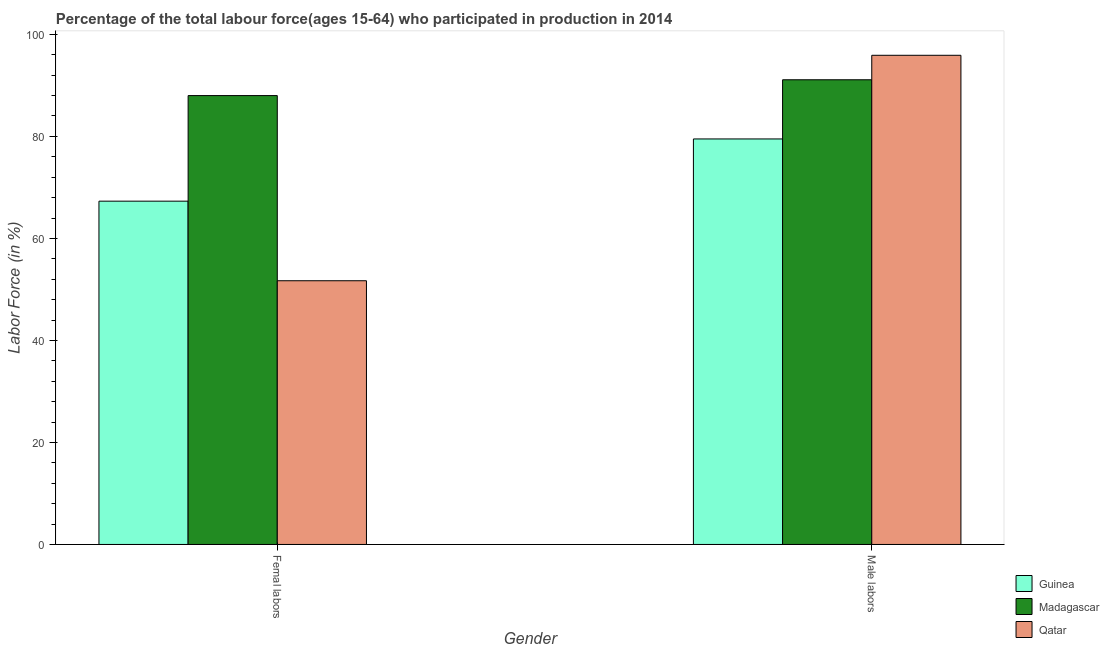How many groups of bars are there?
Your answer should be compact. 2. Are the number of bars on each tick of the X-axis equal?
Ensure brevity in your answer.  Yes. How many bars are there on the 2nd tick from the right?
Give a very brief answer. 3. What is the label of the 2nd group of bars from the left?
Provide a succinct answer. Male labors. Across all countries, what is the maximum percentage of female labor force?
Keep it short and to the point. 88. Across all countries, what is the minimum percentage of female labor force?
Your answer should be compact. 51.7. In which country was the percentage of male labour force maximum?
Give a very brief answer. Qatar. In which country was the percentage of male labour force minimum?
Offer a very short reply. Guinea. What is the total percentage of female labor force in the graph?
Provide a short and direct response. 207. What is the difference between the percentage of male labour force in Qatar and that in Madagascar?
Offer a terse response. 4.8. What is the difference between the percentage of female labor force in Guinea and the percentage of male labour force in Qatar?
Offer a terse response. -28.6. What is the average percentage of male labour force per country?
Give a very brief answer. 88.83. What is the difference between the percentage of male labour force and percentage of female labor force in Qatar?
Give a very brief answer. 44.2. In how many countries, is the percentage of female labor force greater than 96 %?
Your answer should be compact. 0. What is the ratio of the percentage of female labor force in Guinea to that in Madagascar?
Give a very brief answer. 0.76. Is the percentage of male labour force in Madagascar less than that in Guinea?
Give a very brief answer. No. In how many countries, is the percentage of female labor force greater than the average percentage of female labor force taken over all countries?
Offer a terse response. 1. What does the 3rd bar from the left in Male labors represents?
Make the answer very short. Qatar. What does the 2nd bar from the right in Male labors represents?
Make the answer very short. Madagascar. How many countries are there in the graph?
Your response must be concise. 3. What is the difference between two consecutive major ticks on the Y-axis?
Your answer should be very brief. 20. Are the values on the major ticks of Y-axis written in scientific E-notation?
Offer a terse response. No. Does the graph contain any zero values?
Offer a very short reply. No. Does the graph contain grids?
Provide a short and direct response. No. How are the legend labels stacked?
Your response must be concise. Vertical. What is the title of the graph?
Keep it short and to the point. Percentage of the total labour force(ages 15-64) who participated in production in 2014. What is the label or title of the X-axis?
Offer a terse response. Gender. What is the label or title of the Y-axis?
Your answer should be very brief. Labor Force (in %). What is the Labor Force (in %) in Guinea in Femal labors?
Your answer should be compact. 67.3. What is the Labor Force (in %) of Qatar in Femal labors?
Offer a very short reply. 51.7. What is the Labor Force (in %) of Guinea in Male labors?
Your answer should be compact. 79.5. What is the Labor Force (in %) of Madagascar in Male labors?
Give a very brief answer. 91.1. What is the Labor Force (in %) in Qatar in Male labors?
Make the answer very short. 95.9. Across all Gender, what is the maximum Labor Force (in %) in Guinea?
Keep it short and to the point. 79.5. Across all Gender, what is the maximum Labor Force (in %) in Madagascar?
Ensure brevity in your answer.  91.1. Across all Gender, what is the maximum Labor Force (in %) of Qatar?
Ensure brevity in your answer.  95.9. Across all Gender, what is the minimum Labor Force (in %) in Guinea?
Keep it short and to the point. 67.3. Across all Gender, what is the minimum Labor Force (in %) in Qatar?
Your response must be concise. 51.7. What is the total Labor Force (in %) of Guinea in the graph?
Make the answer very short. 146.8. What is the total Labor Force (in %) of Madagascar in the graph?
Give a very brief answer. 179.1. What is the total Labor Force (in %) of Qatar in the graph?
Offer a very short reply. 147.6. What is the difference between the Labor Force (in %) in Guinea in Femal labors and that in Male labors?
Provide a succinct answer. -12.2. What is the difference between the Labor Force (in %) in Madagascar in Femal labors and that in Male labors?
Ensure brevity in your answer.  -3.1. What is the difference between the Labor Force (in %) in Qatar in Femal labors and that in Male labors?
Offer a terse response. -44.2. What is the difference between the Labor Force (in %) in Guinea in Femal labors and the Labor Force (in %) in Madagascar in Male labors?
Provide a succinct answer. -23.8. What is the difference between the Labor Force (in %) in Guinea in Femal labors and the Labor Force (in %) in Qatar in Male labors?
Offer a terse response. -28.6. What is the difference between the Labor Force (in %) of Madagascar in Femal labors and the Labor Force (in %) of Qatar in Male labors?
Keep it short and to the point. -7.9. What is the average Labor Force (in %) in Guinea per Gender?
Offer a very short reply. 73.4. What is the average Labor Force (in %) in Madagascar per Gender?
Offer a terse response. 89.55. What is the average Labor Force (in %) of Qatar per Gender?
Your answer should be compact. 73.8. What is the difference between the Labor Force (in %) in Guinea and Labor Force (in %) in Madagascar in Femal labors?
Your answer should be compact. -20.7. What is the difference between the Labor Force (in %) in Madagascar and Labor Force (in %) in Qatar in Femal labors?
Provide a short and direct response. 36.3. What is the difference between the Labor Force (in %) in Guinea and Labor Force (in %) in Qatar in Male labors?
Provide a succinct answer. -16.4. What is the difference between the Labor Force (in %) of Madagascar and Labor Force (in %) of Qatar in Male labors?
Provide a succinct answer. -4.8. What is the ratio of the Labor Force (in %) in Guinea in Femal labors to that in Male labors?
Keep it short and to the point. 0.85. What is the ratio of the Labor Force (in %) in Qatar in Femal labors to that in Male labors?
Offer a terse response. 0.54. What is the difference between the highest and the second highest Labor Force (in %) in Madagascar?
Ensure brevity in your answer.  3.1. What is the difference between the highest and the second highest Labor Force (in %) of Qatar?
Provide a short and direct response. 44.2. What is the difference between the highest and the lowest Labor Force (in %) in Guinea?
Offer a terse response. 12.2. What is the difference between the highest and the lowest Labor Force (in %) of Madagascar?
Offer a very short reply. 3.1. What is the difference between the highest and the lowest Labor Force (in %) in Qatar?
Make the answer very short. 44.2. 